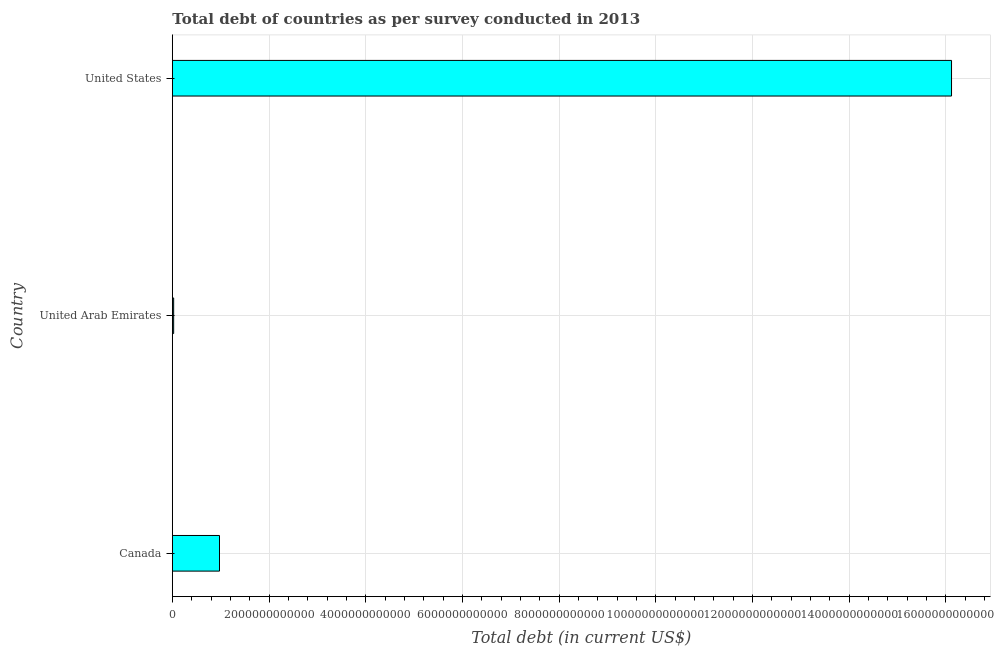Does the graph contain any zero values?
Ensure brevity in your answer.  No. What is the title of the graph?
Offer a terse response. Total debt of countries as per survey conducted in 2013. What is the label or title of the X-axis?
Provide a succinct answer. Total debt (in current US$). What is the total debt in United Arab Emirates?
Keep it short and to the point. 2.71e+1. Across all countries, what is the maximum total debt?
Give a very brief answer. 1.61e+13. Across all countries, what is the minimum total debt?
Ensure brevity in your answer.  2.71e+1. In which country was the total debt maximum?
Your answer should be very brief. United States. In which country was the total debt minimum?
Offer a terse response. United Arab Emirates. What is the sum of the total debt?
Offer a very short reply. 1.71e+13. What is the difference between the total debt in Canada and United Arab Emirates?
Make the answer very short. 9.48e+11. What is the average total debt per country?
Ensure brevity in your answer.  5.71e+12. What is the median total debt?
Keep it short and to the point. 9.75e+11. In how many countries, is the total debt greater than 400000000000 US$?
Make the answer very short. 2. What is the ratio of the total debt in United Arab Emirates to that in United States?
Your answer should be very brief. 0. Is the difference between the total debt in United Arab Emirates and United States greater than the difference between any two countries?
Keep it short and to the point. Yes. What is the difference between the highest and the second highest total debt?
Make the answer very short. 1.51e+13. What is the difference between the highest and the lowest total debt?
Keep it short and to the point. 1.61e+13. Are all the bars in the graph horizontal?
Your response must be concise. Yes. How many countries are there in the graph?
Provide a succinct answer. 3. What is the difference between two consecutive major ticks on the X-axis?
Provide a succinct answer. 2.00e+12. Are the values on the major ticks of X-axis written in scientific E-notation?
Provide a succinct answer. No. What is the Total debt (in current US$) in Canada?
Give a very brief answer. 9.75e+11. What is the Total debt (in current US$) of United Arab Emirates?
Provide a short and direct response. 2.71e+1. What is the Total debt (in current US$) of United States?
Make the answer very short. 1.61e+13. What is the difference between the Total debt (in current US$) in Canada and United Arab Emirates?
Ensure brevity in your answer.  9.48e+11. What is the difference between the Total debt (in current US$) in Canada and United States?
Provide a short and direct response. -1.51e+13. What is the difference between the Total debt (in current US$) in United Arab Emirates and United States?
Ensure brevity in your answer.  -1.61e+13. What is the ratio of the Total debt (in current US$) in Canada to that in United Arab Emirates?
Keep it short and to the point. 35.96. What is the ratio of the Total debt (in current US$) in Canada to that in United States?
Make the answer very short. 0.06. What is the ratio of the Total debt (in current US$) in United Arab Emirates to that in United States?
Offer a terse response. 0. 